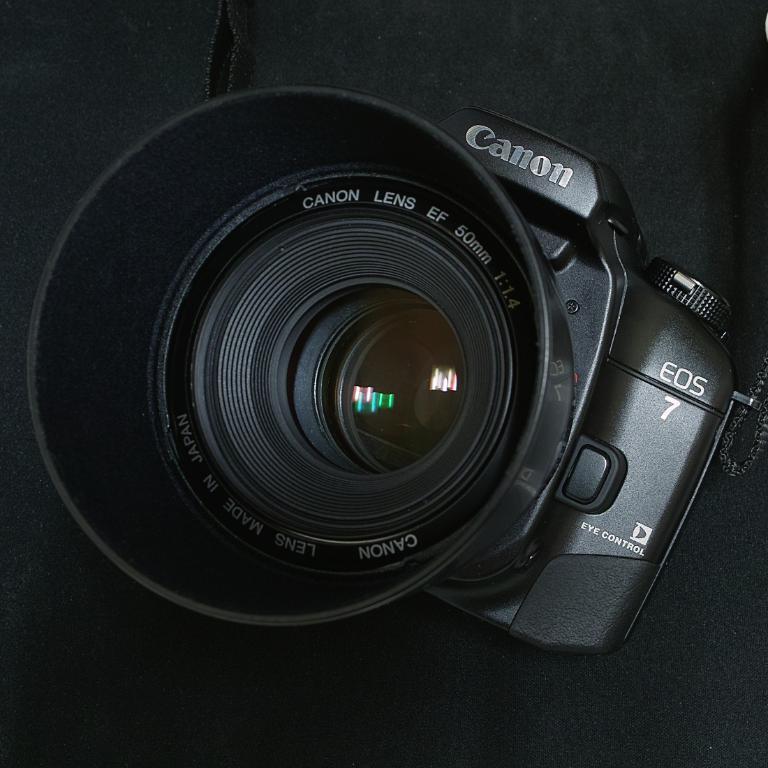How would you summarize this image in a sentence or two? In this image there is a camera. 